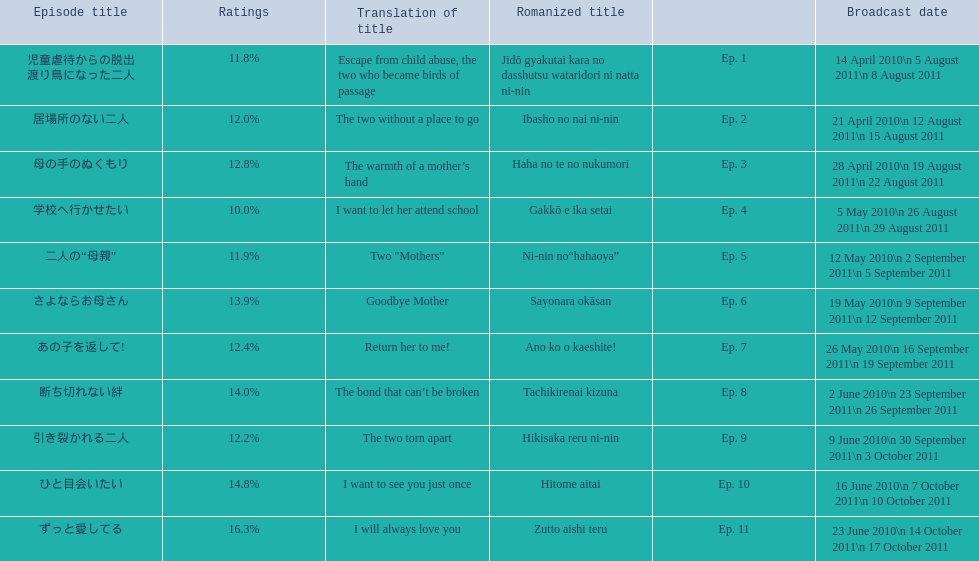Which episode was titled i want to let her attend school? Ep. 4. 